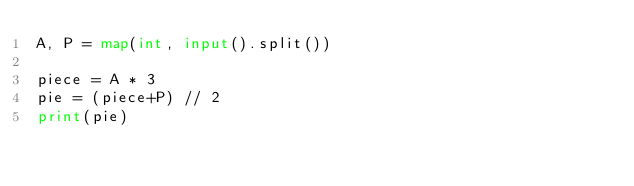Convert code to text. <code><loc_0><loc_0><loc_500><loc_500><_Python_>A, P = map(int, input().split())

piece = A * 3
pie = (piece+P) // 2
print(pie)


</code> 